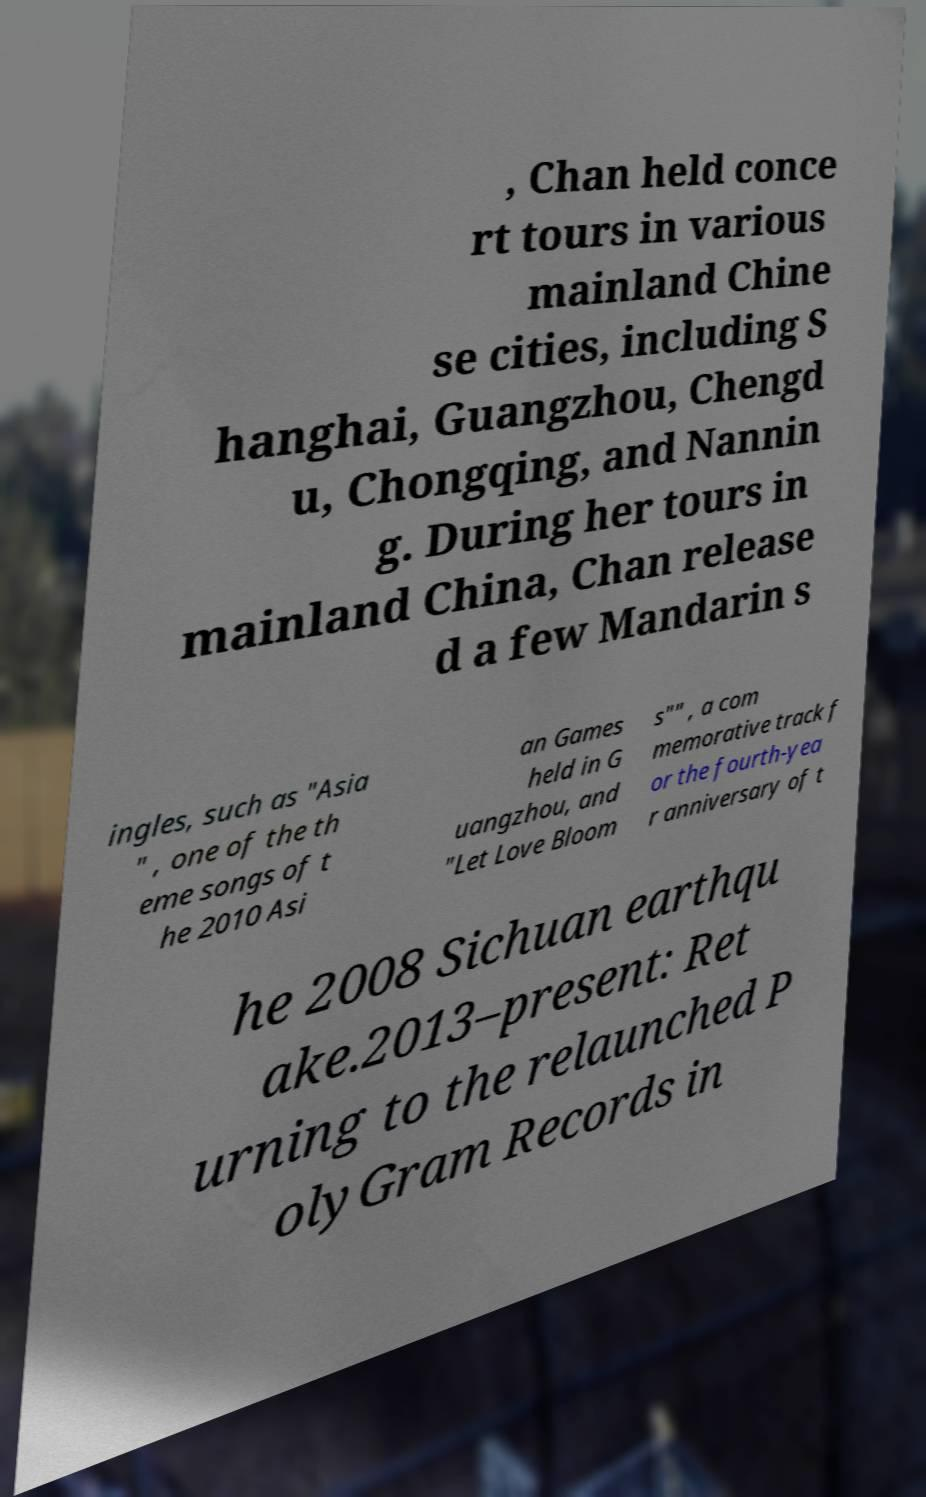I need the written content from this picture converted into text. Can you do that? , Chan held conce rt tours in various mainland Chine se cities, including S hanghai, Guangzhou, Chengd u, Chongqing, and Nannin g. During her tours in mainland China, Chan release d a few Mandarin s ingles, such as "Asia " , one of the th eme songs of t he 2010 Asi an Games held in G uangzhou, and "Let Love Bloom s"" , a com memorative track f or the fourth-yea r anniversary of t he 2008 Sichuan earthqu ake.2013–present: Ret urning to the relaunched P olyGram Records in 